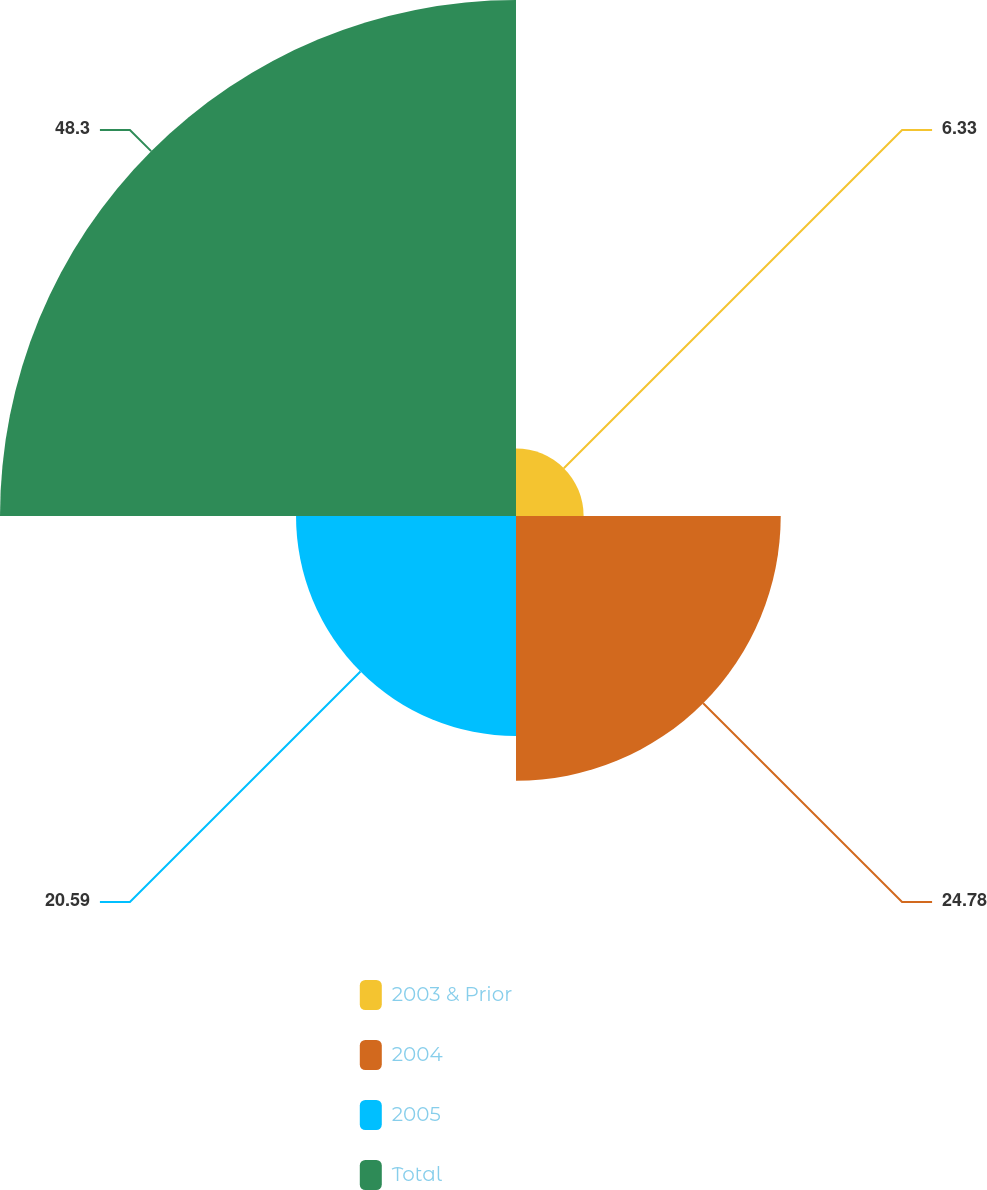Convert chart to OTSL. <chart><loc_0><loc_0><loc_500><loc_500><pie_chart><fcel>2003 & Prior<fcel>2004<fcel>2005<fcel>Total<nl><fcel>6.33%<fcel>24.78%<fcel>20.59%<fcel>48.3%<nl></chart> 